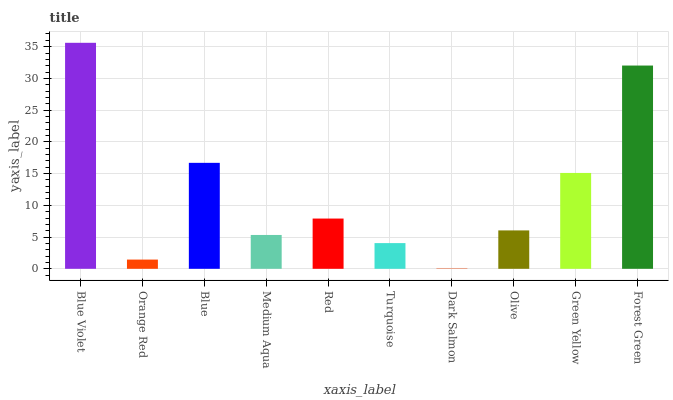Is Orange Red the minimum?
Answer yes or no. No. Is Orange Red the maximum?
Answer yes or no. No. Is Blue Violet greater than Orange Red?
Answer yes or no. Yes. Is Orange Red less than Blue Violet?
Answer yes or no. Yes. Is Orange Red greater than Blue Violet?
Answer yes or no. No. Is Blue Violet less than Orange Red?
Answer yes or no. No. Is Red the high median?
Answer yes or no. Yes. Is Olive the low median?
Answer yes or no. Yes. Is Forest Green the high median?
Answer yes or no. No. Is Forest Green the low median?
Answer yes or no. No. 